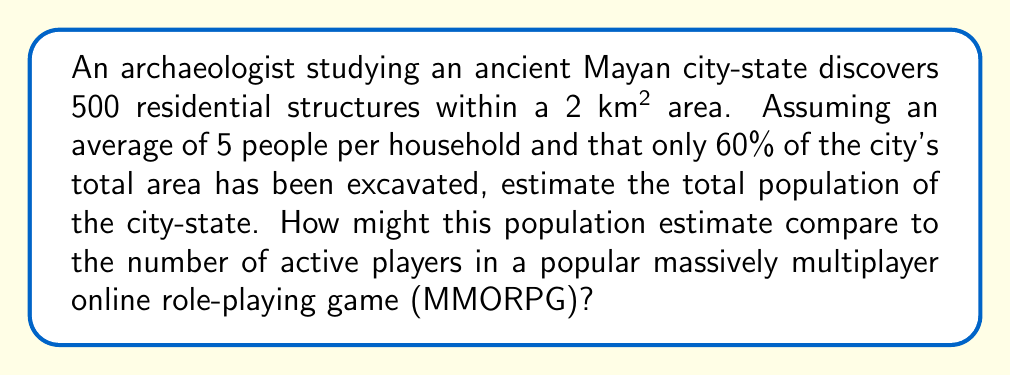Can you solve this math problem? Let's approach this problem step-by-step:

1. Calculate the population density of the excavated area:
   * Number of structures: 500
   * People per household: 5
   * Population in excavated area: $500 \times 5 = 2500$ people
   * Excavated area: 2 km²
   * Population density: $\frac{2500 \text{ people}}{2 \text{ km}^2} = 1250 \text{ people/km}^2$

2. Estimate the total area of the city-state:
   * Excavated area represents 60% of the total
   * Total area = $\frac{2 \text{ km}^2}{0.6} = 3.33 \text{ km}^2$

3. Estimate the total population:
   * Assuming uniform population density
   * Total population = Population density $\times$ Total area
   * $1250 \text{ people/km}^2 \times 3.33 \text{ km}^2 = 4162.5$ people

4. Round to a reasonable estimate: 4,200 people

Comparison to MMORPG:
Popular MMORPGs can have millions of active players. For example, World of Warcraft had around 4.7 million active players in 2022. This is about 1,119 times larger than our estimated ancient Mayan city-state population.

The comparison between ancient populations and modern online gaming communities can provide interesting insights into social structures, resource management, and community dynamics across different eras and contexts.
Answer: The estimated population of the ancient Mayan city-state is approximately 4,200 people. 